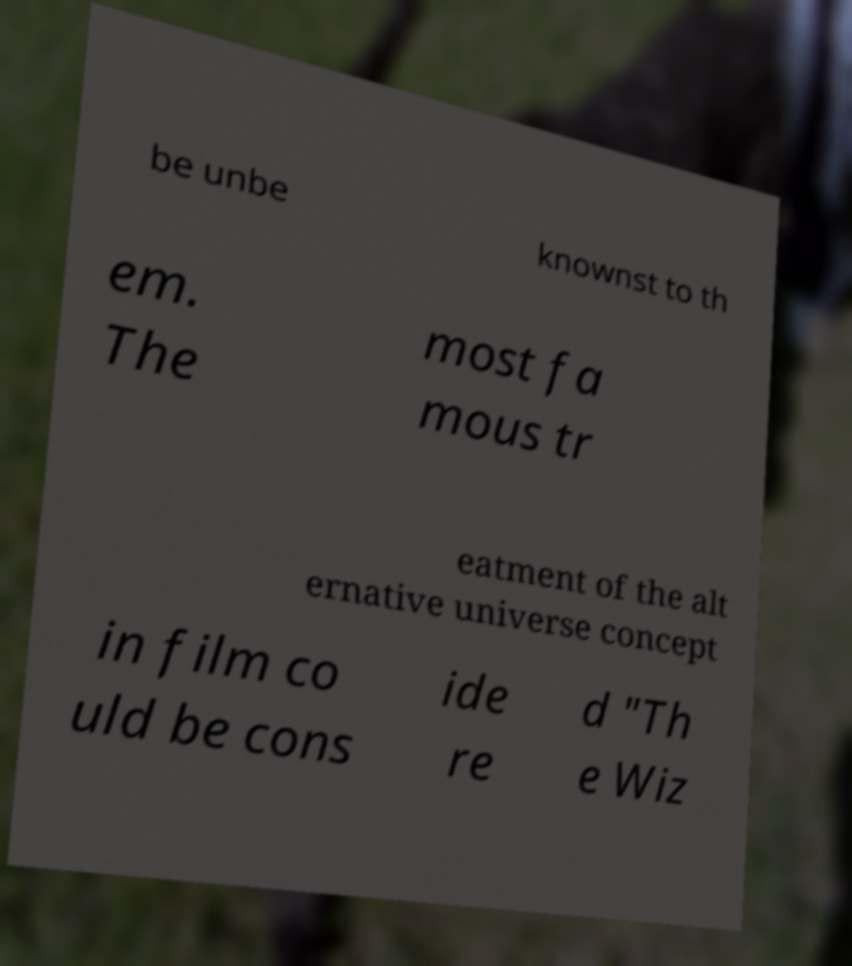I need the written content from this picture converted into text. Can you do that? be unbe knownst to th em. The most fa mous tr eatment of the alt ernative universe concept in film co uld be cons ide re d "Th e Wiz 